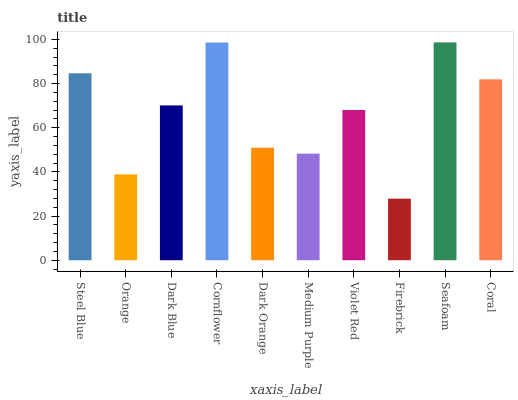Is Orange the minimum?
Answer yes or no. No. Is Orange the maximum?
Answer yes or no. No. Is Steel Blue greater than Orange?
Answer yes or no. Yes. Is Orange less than Steel Blue?
Answer yes or no. Yes. Is Orange greater than Steel Blue?
Answer yes or no. No. Is Steel Blue less than Orange?
Answer yes or no. No. Is Dark Blue the high median?
Answer yes or no. Yes. Is Violet Red the low median?
Answer yes or no. Yes. Is Firebrick the high median?
Answer yes or no. No. Is Dark Orange the low median?
Answer yes or no. No. 